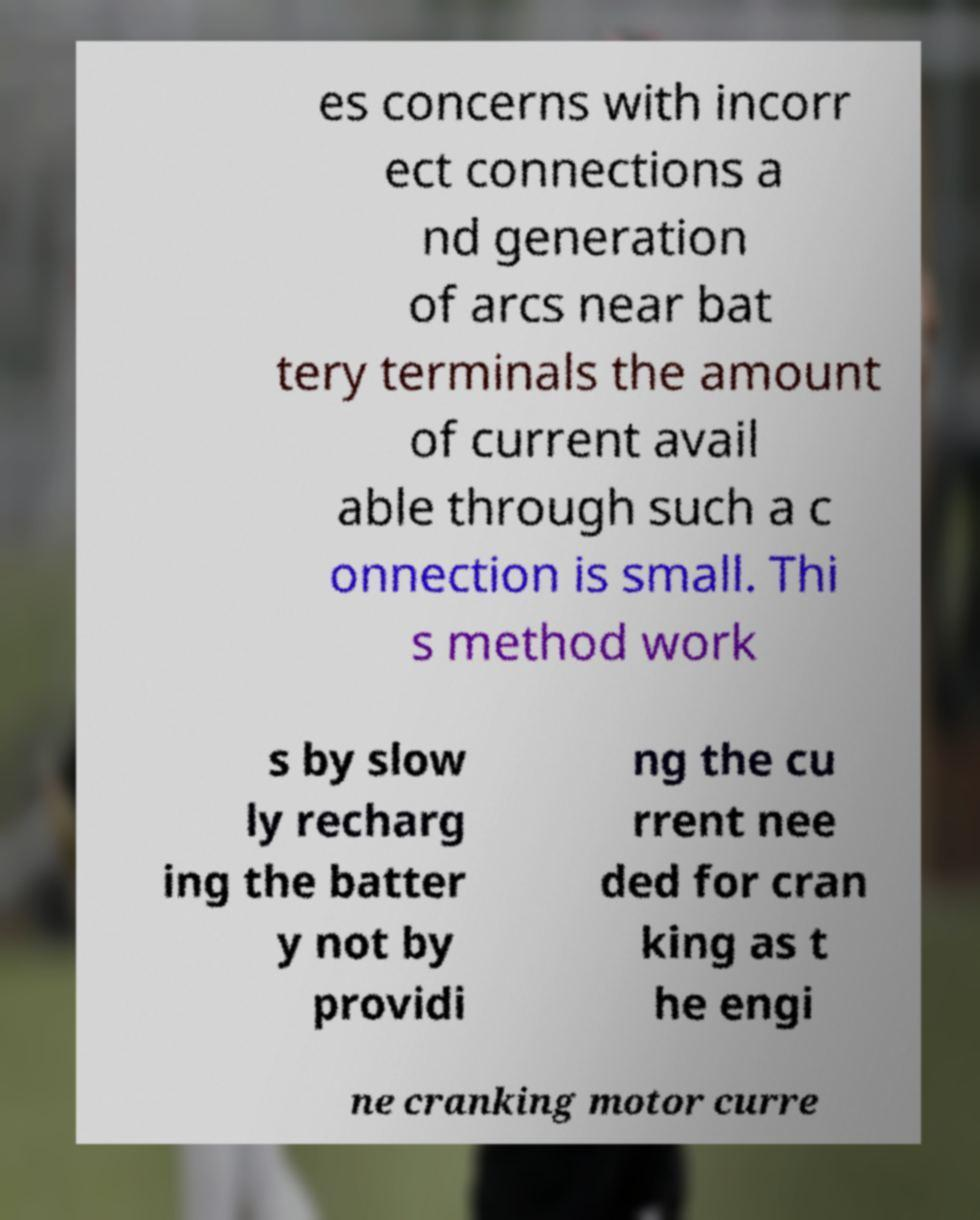What messages or text are displayed in this image? I need them in a readable, typed format. es concerns with incorr ect connections a nd generation of arcs near bat tery terminals the amount of current avail able through such a c onnection is small. Thi s method work s by slow ly recharg ing the batter y not by providi ng the cu rrent nee ded for cran king as t he engi ne cranking motor curre 